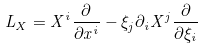<formula> <loc_0><loc_0><loc_500><loc_500>L _ { X } = X ^ { i } \frac { \partial } { \partial x ^ { i } } - \xi _ { j } \partial _ { i } X ^ { j } \frac { \partial } { \partial \xi _ { i } }</formula> 